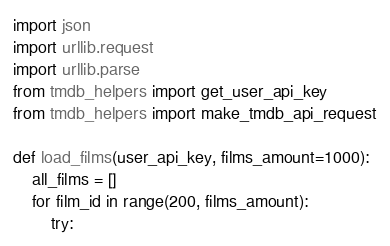<code> <loc_0><loc_0><loc_500><loc_500><_Python_>import json
import urllib.request
import urllib.parse
from tmdb_helpers import get_user_api_key
from tmdb_helpers import make_tmdb_api_request

def load_films(user_api_key, films_amount=1000):
    all_films = []
    for film_id in range(200, films_amount):
        try:</code> 